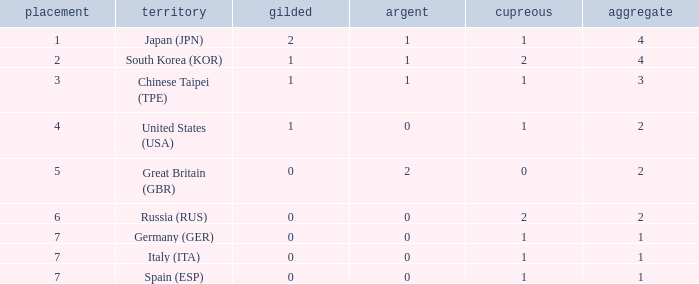What is the smallest number of gold of a country of rank 6, with 2 bronzes? None. Would you mind parsing the complete table? {'header': ['placement', 'territory', 'gilded', 'argent', 'cupreous', 'aggregate'], 'rows': [['1', 'Japan (JPN)', '2', '1', '1', '4'], ['2', 'South Korea (KOR)', '1', '1', '2', '4'], ['3', 'Chinese Taipei (TPE)', '1', '1', '1', '3'], ['4', 'United States (USA)', '1', '0', '1', '2'], ['5', 'Great Britain (GBR)', '0', '2', '0', '2'], ['6', 'Russia (RUS)', '0', '0', '2', '2'], ['7', 'Germany (GER)', '0', '0', '1', '1'], ['7', 'Italy (ITA)', '0', '0', '1', '1'], ['7', 'Spain (ESP)', '0', '0', '1', '1']]} 